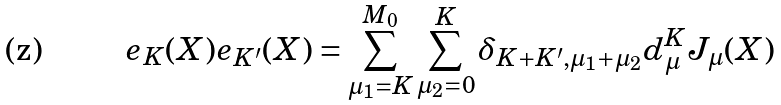Convert formula to latex. <formula><loc_0><loc_0><loc_500><loc_500>e _ { K } ( X ) e _ { K ^ { \prime } } ( X ) = \sum _ { \mu _ { 1 } = K } ^ { M _ { 0 } } \sum _ { \mu _ { 2 } = 0 } ^ { K } \delta _ { K + K ^ { \prime } , \mu _ { 1 } + \mu _ { 2 } } d _ { \mu } ^ { K } J _ { \mu } ( X )</formula> 